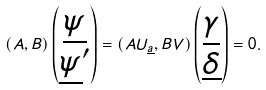Convert formula to latex. <formula><loc_0><loc_0><loc_500><loc_500>( A , B ) \begin{pmatrix} \underline { \psi } \\ \underline { \psi } ^ { \prime } \end{pmatrix} = ( A U _ { \underline { a } } , B V ) \begin{pmatrix} \underline { \gamma } \\ \underline { \delta } \end{pmatrix} = 0 .</formula> 